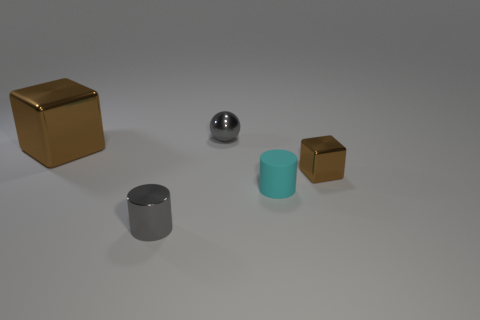Which object seems to be the heaviest and why? Judging by the materials they appear to be made of, the golden cube might be the heaviest because it looks like it's made of metal, which is typically denser than the materials of the other objects like rubber for the cyan cylinder and potentially cardboard for the brown cube. 